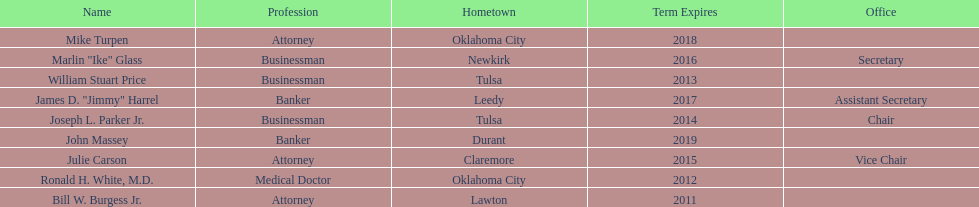How many of the current state regents will be in office until at least 2016? 4. Can you parse all the data within this table? {'header': ['Name', 'Profession', 'Hometown', 'Term Expires', 'Office'], 'rows': [['Mike Turpen', 'Attorney', 'Oklahoma City', '2018', ''], ['Marlin "Ike" Glass', 'Businessman', 'Newkirk', '2016', 'Secretary'], ['William Stuart Price', 'Businessman', 'Tulsa', '2013', ''], ['James D. "Jimmy" Harrel', 'Banker', 'Leedy', '2017', 'Assistant Secretary'], ['Joseph L. Parker Jr.', 'Businessman', 'Tulsa', '2014', 'Chair'], ['John Massey', 'Banker', 'Durant', '2019', ''], ['Julie Carson', 'Attorney', 'Claremore', '2015', 'Vice Chair'], ['Ronald H. White, M.D.', 'Medical Doctor', 'Oklahoma City', '2012', ''], ['Bill W. Burgess Jr.', 'Attorney', 'Lawton', '2011', '']]} 